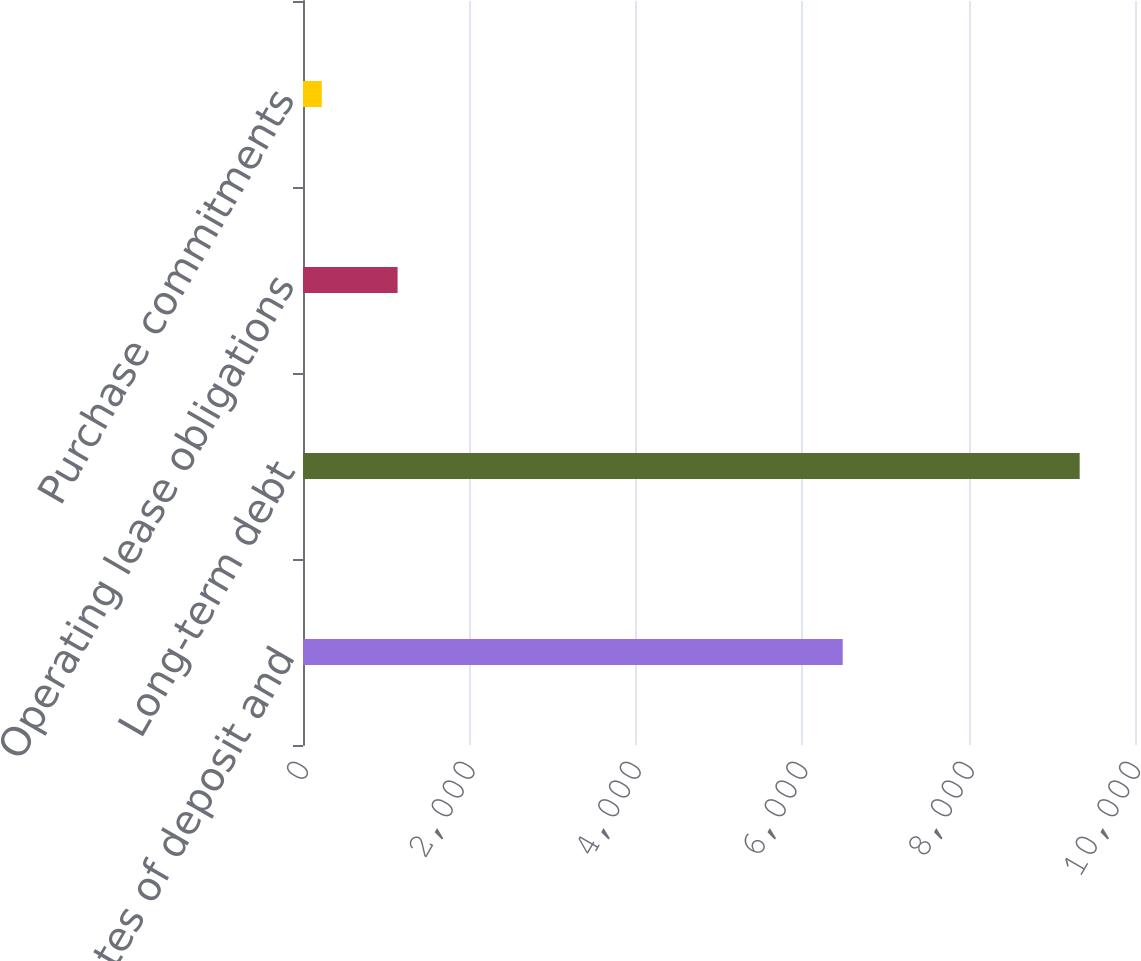Convert chart to OTSL. <chart><loc_0><loc_0><loc_500><loc_500><bar_chart><fcel>Certificates of deposit and<fcel>Long-term debt<fcel>Operating lease obligations<fcel>Purchase commitments<nl><fcel>6487<fcel>9335<fcel>1136.9<fcel>226<nl></chart> 